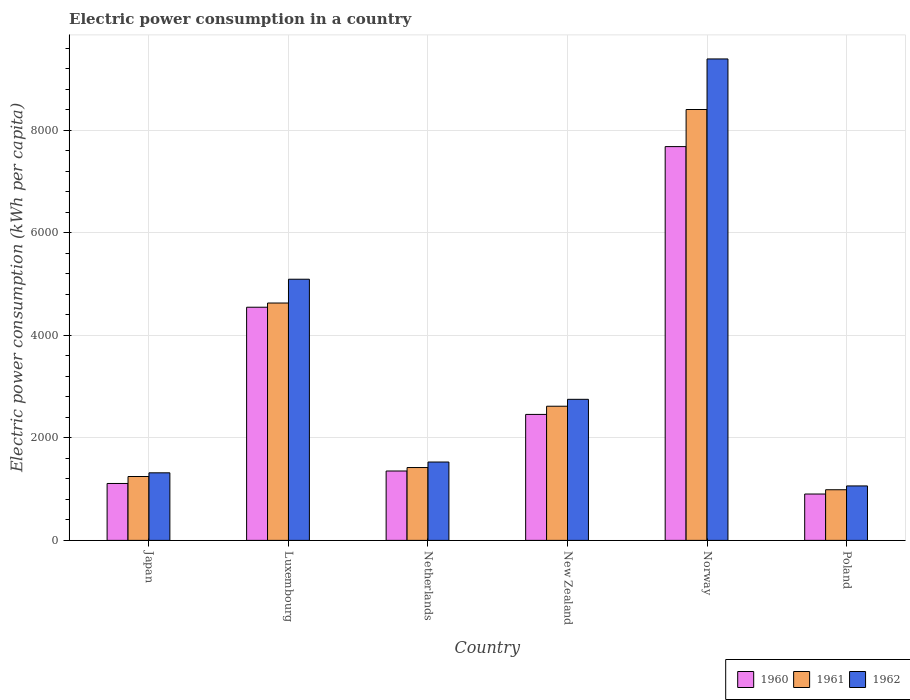How many different coloured bars are there?
Provide a short and direct response. 3. How many groups of bars are there?
Offer a terse response. 6. How many bars are there on the 4th tick from the left?
Your answer should be compact. 3. What is the label of the 3rd group of bars from the left?
Ensure brevity in your answer.  Netherlands. What is the electric power consumption in in 1962 in Luxembourg?
Ensure brevity in your answer.  5094.31. Across all countries, what is the maximum electric power consumption in in 1962?
Make the answer very short. 9390.98. Across all countries, what is the minimum electric power consumption in in 1960?
Your answer should be compact. 904.57. What is the total electric power consumption in in 1960 in the graph?
Your answer should be very brief. 1.81e+04. What is the difference between the electric power consumption in in 1962 in Japan and that in Netherlands?
Provide a succinct answer. -210.57. What is the difference between the electric power consumption in in 1961 in Norway and the electric power consumption in in 1960 in Japan?
Offer a terse response. 7294.36. What is the average electric power consumption in in 1960 per country?
Your answer should be very brief. 3009.13. What is the difference between the electric power consumption in of/in 1960 and electric power consumption in of/in 1962 in Norway?
Your answer should be very brief. -1709.84. What is the ratio of the electric power consumption in in 1961 in Netherlands to that in Poland?
Offer a very short reply. 1.44. What is the difference between the highest and the second highest electric power consumption in in 1960?
Keep it short and to the point. 5223.94. What is the difference between the highest and the lowest electric power consumption in in 1961?
Offer a terse response. 7416.7. In how many countries, is the electric power consumption in in 1961 greater than the average electric power consumption in in 1961 taken over all countries?
Offer a very short reply. 2. What does the 1st bar from the right in Netherlands represents?
Ensure brevity in your answer.  1962. Is it the case that in every country, the sum of the electric power consumption in in 1961 and electric power consumption in in 1962 is greater than the electric power consumption in in 1960?
Make the answer very short. Yes. How many bars are there?
Offer a very short reply. 18. Are all the bars in the graph horizontal?
Your answer should be very brief. No. How many countries are there in the graph?
Make the answer very short. 6. What is the difference between two consecutive major ticks on the Y-axis?
Provide a short and direct response. 2000. Are the values on the major ticks of Y-axis written in scientific E-notation?
Keep it short and to the point. No. Does the graph contain grids?
Ensure brevity in your answer.  Yes. How many legend labels are there?
Provide a succinct answer. 3. What is the title of the graph?
Provide a succinct answer. Electric power consumption in a country. Does "1973" appear as one of the legend labels in the graph?
Your answer should be very brief. No. What is the label or title of the Y-axis?
Offer a terse response. Electric power consumption (kWh per capita). What is the Electric power consumption (kWh per capita) in 1960 in Japan?
Offer a very short reply. 1110.26. What is the Electric power consumption (kWh per capita) in 1961 in Japan?
Offer a very short reply. 1246.01. What is the Electric power consumption (kWh per capita) in 1962 in Japan?
Offer a very short reply. 1317.93. What is the Electric power consumption (kWh per capita) of 1960 in Luxembourg?
Provide a succinct answer. 4548.21. What is the Electric power consumption (kWh per capita) of 1961 in Luxembourg?
Offer a terse response. 4630.02. What is the Electric power consumption (kWh per capita) of 1962 in Luxembourg?
Keep it short and to the point. 5094.31. What is the Electric power consumption (kWh per capita) in 1960 in Netherlands?
Your answer should be very brief. 1353.4. What is the Electric power consumption (kWh per capita) in 1961 in Netherlands?
Your answer should be compact. 1421.03. What is the Electric power consumption (kWh per capita) in 1962 in Netherlands?
Your answer should be compact. 1528.5. What is the Electric power consumption (kWh per capita) of 1960 in New Zealand?
Provide a short and direct response. 2457.21. What is the Electric power consumption (kWh per capita) of 1961 in New Zealand?
Ensure brevity in your answer.  2616.85. What is the Electric power consumption (kWh per capita) of 1962 in New Zealand?
Offer a terse response. 2751.81. What is the Electric power consumption (kWh per capita) in 1960 in Norway?
Your response must be concise. 7681.14. What is the Electric power consumption (kWh per capita) in 1961 in Norway?
Provide a succinct answer. 8404.62. What is the Electric power consumption (kWh per capita) of 1962 in Norway?
Provide a short and direct response. 9390.98. What is the Electric power consumption (kWh per capita) in 1960 in Poland?
Ensure brevity in your answer.  904.57. What is the Electric power consumption (kWh per capita) in 1961 in Poland?
Provide a succinct answer. 987.92. What is the Electric power consumption (kWh per capita) of 1962 in Poland?
Offer a terse response. 1062.18. Across all countries, what is the maximum Electric power consumption (kWh per capita) in 1960?
Your response must be concise. 7681.14. Across all countries, what is the maximum Electric power consumption (kWh per capita) in 1961?
Give a very brief answer. 8404.62. Across all countries, what is the maximum Electric power consumption (kWh per capita) in 1962?
Make the answer very short. 9390.98. Across all countries, what is the minimum Electric power consumption (kWh per capita) in 1960?
Make the answer very short. 904.57. Across all countries, what is the minimum Electric power consumption (kWh per capita) of 1961?
Keep it short and to the point. 987.92. Across all countries, what is the minimum Electric power consumption (kWh per capita) of 1962?
Your response must be concise. 1062.18. What is the total Electric power consumption (kWh per capita) in 1960 in the graph?
Ensure brevity in your answer.  1.81e+04. What is the total Electric power consumption (kWh per capita) of 1961 in the graph?
Keep it short and to the point. 1.93e+04. What is the total Electric power consumption (kWh per capita) of 1962 in the graph?
Ensure brevity in your answer.  2.11e+04. What is the difference between the Electric power consumption (kWh per capita) in 1960 in Japan and that in Luxembourg?
Your response must be concise. -3437.94. What is the difference between the Electric power consumption (kWh per capita) of 1961 in Japan and that in Luxembourg?
Ensure brevity in your answer.  -3384.01. What is the difference between the Electric power consumption (kWh per capita) in 1962 in Japan and that in Luxembourg?
Provide a short and direct response. -3776.38. What is the difference between the Electric power consumption (kWh per capita) of 1960 in Japan and that in Netherlands?
Offer a terse response. -243.14. What is the difference between the Electric power consumption (kWh per capita) in 1961 in Japan and that in Netherlands?
Your answer should be compact. -175.02. What is the difference between the Electric power consumption (kWh per capita) in 1962 in Japan and that in Netherlands?
Your response must be concise. -210.57. What is the difference between the Electric power consumption (kWh per capita) of 1960 in Japan and that in New Zealand?
Give a very brief answer. -1346.94. What is the difference between the Electric power consumption (kWh per capita) of 1961 in Japan and that in New Zealand?
Your answer should be very brief. -1370.84. What is the difference between the Electric power consumption (kWh per capita) of 1962 in Japan and that in New Zealand?
Offer a very short reply. -1433.88. What is the difference between the Electric power consumption (kWh per capita) of 1960 in Japan and that in Norway?
Ensure brevity in your answer.  -6570.88. What is the difference between the Electric power consumption (kWh per capita) in 1961 in Japan and that in Norway?
Offer a terse response. -7158.61. What is the difference between the Electric power consumption (kWh per capita) of 1962 in Japan and that in Norway?
Provide a succinct answer. -8073.05. What is the difference between the Electric power consumption (kWh per capita) of 1960 in Japan and that in Poland?
Provide a succinct answer. 205.7. What is the difference between the Electric power consumption (kWh per capita) in 1961 in Japan and that in Poland?
Ensure brevity in your answer.  258.09. What is the difference between the Electric power consumption (kWh per capita) of 1962 in Japan and that in Poland?
Keep it short and to the point. 255.75. What is the difference between the Electric power consumption (kWh per capita) of 1960 in Luxembourg and that in Netherlands?
Offer a terse response. 3194.81. What is the difference between the Electric power consumption (kWh per capita) of 1961 in Luxembourg and that in Netherlands?
Offer a terse response. 3208.99. What is the difference between the Electric power consumption (kWh per capita) in 1962 in Luxembourg and that in Netherlands?
Give a very brief answer. 3565.81. What is the difference between the Electric power consumption (kWh per capita) in 1960 in Luxembourg and that in New Zealand?
Make the answer very short. 2091. What is the difference between the Electric power consumption (kWh per capita) of 1961 in Luxembourg and that in New Zealand?
Your response must be concise. 2013.17. What is the difference between the Electric power consumption (kWh per capita) in 1962 in Luxembourg and that in New Zealand?
Make the answer very short. 2342.5. What is the difference between the Electric power consumption (kWh per capita) in 1960 in Luxembourg and that in Norway?
Provide a short and direct response. -3132.94. What is the difference between the Electric power consumption (kWh per capita) of 1961 in Luxembourg and that in Norway?
Offer a very short reply. -3774.6. What is the difference between the Electric power consumption (kWh per capita) in 1962 in Luxembourg and that in Norway?
Your answer should be very brief. -4296.67. What is the difference between the Electric power consumption (kWh per capita) in 1960 in Luxembourg and that in Poland?
Offer a terse response. 3643.64. What is the difference between the Electric power consumption (kWh per capita) in 1961 in Luxembourg and that in Poland?
Your answer should be compact. 3642.11. What is the difference between the Electric power consumption (kWh per capita) in 1962 in Luxembourg and that in Poland?
Your answer should be very brief. 4032.13. What is the difference between the Electric power consumption (kWh per capita) in 1960 in Netherlands and that in New Zealand?
Make the answer very short. -1103.81. What is the difference between the Electric power consumption (kWh per capita) in 1961 in Netherlands and that in New Zealand?
Give a very brief answer. -1195.82. What is the difference between the Electric power consumption (kWh per capita) of 1962 in Netherlands and that in New Zealand?
Your response must be concise. -1223.31. What is the difference between the Electric power consumption (kWh per capita) in 1960 in Netherlands and that in Norway?
Your answer should be compact. -6327.74. What is the difference between the Electric power consumption (kWh per capita) in 1961 in Netherlands and that in Norway?
Give a very brief answer. -6983.59. What is the difference between the Electric power consumption (kWh per capita) in 1962 in Netherlands and that in Norway?
Offer a very short reply. -7862.48. What is the difference between the Electric power consumption (kWh per capita) in 1960 in Netherlands and that in Poland?
Provide a short and direct response. 448.83. What is the difference between the Electric power consumption (kWh per capita) in 1961 in Netherlands and that in Poland?
Offer a very short reply. 433.11. What is the difference between the Electric power consumption (kWh per capita) of 1962 in Netherlands and that in Poland?
Give a very brief answer. 466.32. What is the difference between the Electric power consumption (kWh per capita) of 1960 in New Zealand and that in Norway?
Offer a terse response. -5223.94. What is the difference between the Electric power consumption (kWh per capita) in 1961 in New Zealand and that in Norway?
Provide a short and direct response. -5787.77. What is the difference between the Electric power consumption (kWh per capita) of 1962 in New Zealand and that in Norway?
Ensure brevity in your answer.  -6639.17. What is the difference between the Electric power consumption (kWh per capita) in 1960 in New Zealand and that in Poland?
Offer a terse response. 1552.64. What is the difference between the Electric power consumption (kWh per capita) of 1961 in New Zealand and that in Poland?
Offer a very short reply. 1628.93. What is the difference between the Electric power consumption (kWh per capita) of 1962 in New Zealand and that in Poland?
Your answer should be compact. 1689.64. What is the difference between the Electric power consumption (kWh per capita) in 1960 in Norway and that in Poland?
Offer a terse response. 6776.58. What is the difference between the Electric power consumption (kWh per capita) in 1961 in Norway and that in Poland?
Ensure brevity in your answer.  7416.7. What is the difference between the Electric power consumption (kWh per capita) in 1962 in Norway and that in Poland?
Your response must be concise. 8328.8. What is the difference between the Electric power consumption (kWh per capita) in 1960 in Japan and the Electric power consumption (kWh per capita) in 1961 in Luxembourg?
Your response must be concise. -3519.76. What is the difference between the Electric power consumption (kWh per capita) of 1960 in Japan and the Electric power consumption (kWh per capita) of 1962 in Luxembourg?
Keep it short and to the point. -3984.05. What is the difference between the Electric power consumption (kWh per capita) in 1961 in Japan and the Electric power consumption (kWh per capita) in 1962 in Luxembourg?
Your answer should be very brief. -3848.3. What is the difference between the Electric power consumption (kWh per capita) in 1960 in Japan and the Electric power consumption (kWh per capita) in 1961 in Netherlands?
Your answer should be compact. -310.77. What is the difference between the Electric power consumption (kWh per capita) of 1960 in Japan and the Electric power consumption (kWh per capita) of 1962 in Netherlands?
Offer a terse response. -418.24. What is the difference between the Electric power consumption (kWh per capita) in 1961 in Japan and the Electric power consumption (kWh per capita) in 1962 in Netherlands?
Provide a short and direct response. -282.49. What is the difference between the Electric power consumption (kWh per capita) of 1960 in Japan and the Electric power consumption (kWh per capita) of 1961 in New Zealand?
Provide a short and direct response. -1506.59. What is the difference between the Electric power consumption (kWh per capita) of 1960 in Japan and the Electric power consumption (kWh per capita) of 1962 in New Zealand?
Provide a short and direct response. -1641.55. What is the difference between the Electric power consumption (kWh per capita) in 1961 in Japan and the Electric power consumption (kWh per capita) in 1962 in New Zealand?
Provide a short and direct response. -1505.8. What is the difference between the Electric power consumption (kWh per capita) of 1960 in Japan and the Electric power consumption (kWh per capita) of 1961 in Norway?
Provide a succinct answer. -7294.36. What is the difference between the Electric power consumption (kWh per capita) of 1960 in Japan and the Electric power consumption (kWh per capita) of 1962 in Norway?
Make the answer very short. -8280.71. What is the difference between the Electric power consumption (kWh per capita) in 1961 in Japan and the Electric power consumption (kWh per capita) in 1962 in Norway?
Provide a succinct answer. -8144.97. What is the difference between the Electric power consumption (kWh per capita) in 1960 in Japan and the Electric power consumption (kWh per capita) in 1961 in Poland?
Your response must be concise. 122.34. What is the difference between the Electric power consumption (kWh per capita) of 1960 in Japan and the Electric power consumption (kWh per capita) of 1962 in Poland?
Ensure brevity in your answer.  48.09. What is the difference between the Electric power consumption (kWh per capita) of 1961 in Japan and the Electric power consumption (kWh per capita) of 1962 in Poland?
Provide a succinct answer. 183.83. What is the difference between the Electric power consumption (kWh per capita) of 1960 in Luxembourg and the Electric power consumption (kWh per capita) of 1961 in Netherlands?
Ensure brevity in your answer.  3127.17. What is the difference between the Electric power consumption (kWh per capita) in 1960 in Luxembourg and the Electric power consumption (kWh per capita) in 1962 in Netherlands?
Your answer should be very brief. 3019.7. What is the difference between the Electric power consumption (kWh per capita) in 1961 in Luxembourg and the Electric power consumption (kWh per capita) in 1962 in Netherlands?
Provide a short and direct response. 3101.52. What is the difference between the Electric power consumption (kWh per capita) of 1960 in Luxembourg and the Electric power consumption (kWh per capita) of 1961 in New Zealand?
Make the answer very short. 1931.35. What is the difference between the Electric power consumption (kWh per capita) in 1960 in Luxembourg and the Electric power consumption (kWh per capita) in 1962 in New Zealand?
Ensure brevity in your answer.  1796.39. What is the difference between the Electric power consumption (kWh per capita) of 1961 in Luxembourg and the Electric power consumption (kWh per capita) of 1962 in New Zealand?
Offer a very short reply. 1878.21. What is the difference between the Electric power consumption (kWh per capita) of 1960 in Luxembourg and the Electric power consumption (kWh per capita) of 1961 in Norway?
Your answer should be very brief. -3856.42. What is the difference between the Electric power consumption (kWh per capita) of 1960 in Luxembourg and the Electric power consumption (kWh per capita) of 1962 in Norway?
Offer a terse response. -4842.77. What is the difference between the Electric power consumption (kWh per capita) of 1961 in Luxembourg and the Electric power consumption (kWh per capita) of 1962 in Norway?
Ensure brevity in your answer.  -4760.95. What is the difference between the Electric power consumption (kWh per capita) in 1960 in Luxembourg and the Electric power consumption (kWh per capita) in 1961 in Poland?
Ensure brevity in your answer.  3560.29. What is the difference between the Electric power consumption (kWh per capita) of 1960 in Luxembourg and the Electric power consumption (kWh per capita) of 1962 in Poland?
Offer a very short reply. 3486.03. What is the difference between the Electric power consumption (kWh per capita) of 1961 in Luxembourg and the Electric power consumption (kWh per capita) of 1962 in Poland?
Provide a short and direct response. 3567.85. What is the difference between the Electric power consumption (kWh per capita) in 1960 in Netherlands and the Electric power consumption (kWh per capita) in 1961 in New Zealand?
Offer a very short reply. -1263.45. What is the difference between the Electric power consumption (kWh per capita) in 1960 in Netherlands and the Electric power consumption (kWh per capita) in 1962 in New Zealand?
Provide a short and direct response. -1398.41. What is the difference between the Electric power consumption (kWh per capita) in 1961 in Netherlands and the Electric power consumption (kWh per capita) in 1962 in New Zealand?
Your answer should be compact. -1330.78. What is the difference between the Electric power consumption (kWh per capita) in 1960 in Netherlands and the Electric power consumption (kWh per capita) in 1961 in Norway?
Ensure brevity in your answer.  -7051.22. What is the difference between the Electric power consumption (kWh per capita) in 1960 in Netherlands and the Electric power consumption (kWh per capita) in 1962 in Norway?
Your answer should be compact. -8037.58. What is the difference between the Electric power consumption (kWh per capita) of 1961 in Netherlands and the Electric power consumption (kWh per capita) of 1962 in Norway?
Offer a terse response. -7969.94. What is the difference between the Electric power consumption (kWh per capita) of 1960 in Netherlands and the Electric power consumption (kWh per capita) of 1961 in Poland?
Provide a short and direct response. 365.48. What is the difference between the Electric power consumption (kWh per capita) of 1960 in Netherlands and the Electric power consumption (kWh per capita) of 1962 in Poland?
Make the answer very short. 291.22. What is the difference between the Electric power consumption (kWh per capita) of 1961 in Netherlands and the Electric power consumption (kWh per capita) of 1962 in Poland?
Ensure brevity in your answer.  358.86. What is the difference between the Electric power consumption (kWh per capita) of 1960 in New Zealand and the Electric power consumption (kWh per capita) of 1961 in Norway?
Your response must be concise. -5947.42. What is the difference between the Electric power consumption (kWh per capita) in 1960 in New Zealand and the Electric power consumption (kWh per capita) in 1962 in Norway?
Your answer should be compact. -6933.77. What is the difference between the Electric power consumption (kWh per capita) in 1961 in New Zealand and the Electric power consumption (kWh per capita) in 1962 in Norway?
Offer a very short reply. -6774.12. What is the difference between the Electric power consumption (kWh per capita) of 1960 in New Zealand and the Electric power consumption (kWh per capita) of 1961 in Poland?
Provide a short and direct response. 1469.29. What is the difference between the Electric power consumption (kWh per capita) in 1960 in New Zealand and the Electric power consumption (kWh per capita) in 1962 in Poland?
Offer a very short reply. 1395.03. What is the difference between the Electric power consumption (kWh per capita) of 1961 in New Zealand and the Electric power consumption (kWh per capita) of 1962 in Poland?
Make the answer very short. 1554.68. What is the difference between the Electric power consumption (kWh per capita) of 1960 in Norway and the Electric power consumption (kWh per capita) of 1961 in Poland?
Make the answer very short. 6693.22. What is the difference between the Electric power consumption (kWh per capita) of 1960 in Norway and the Electric power consumption (kWh per capita) of 1962 in Poland?
Ensure brevity in your answer.  6618.96. What is the difference between the Electric power consumption (kWh per capita) of 1961 in Norway and the Electric power consumption (kWh per capita) of 1962 in Poland?
Make the answer very short. 7342.44. What is the average Electric power consumption (kWh per capita) of 1960 per country?
Your answer should be very brief. 3009.13. What is the average Electric power consumption (kWh per capita) of 1961 per country?
Your response must be concise. 3217.74. What is the average Electric power consumption (kWh per capita) of 1962 per country?
Your answer should be very brief. 3524.29. What is the difference between the Electric power consumption (kWh per capita) of 1960 and Electric power consumption (kWh per capita) of 1961 in Japan?
Give a very brief answer. -135.75. What is the difference between the Electric power consumption (kWh per capita) in 1960 and Electric power consumption (kWh per capita) in 1962 in Japan?
Your answer should be compact. -207.67. What is the difference between the Electric power consumption (kWh per capita) of 1961 and Electric power consumption (kWh per capita) of 1962 in Japan?
Provide a short and direct response. -71.92. What is the difference between the Electric power consumption (kWh per capita) of 1960 and Electric power consumption (kWh per capita) of 1961 in Luxembourg?
Provide a succinct answer. -81.82. What is the difference between the Electric power consumption (kWh per capita) of 1960 and Electric power consumption (kWh per capita) of 1962 in Luxembourg?
Keep it short and to the point. -546.11. What is the difference between the Electric power consumption (kWh per capita) in 1961 and Electric power consumption (kWh per capita) in 1962 in Luxembourg?
Your response must be concise. -464.29. What is the difference between the Electric power consumption (kWh per capita) of 1960 and Electric power consumption (kWh per capita) of 1961 in Netherlands?
Offer a very short reply. -67.63. What is the difference between the Electric power consumption (kWh per capita) in 1960 and Electric power consumption (kWh per capita) in 1962 in Netherlands?
Offer a terse response. -175.1. What is the difference between the Electric power consumption (kWh per capita) of 1961 and Electric power consumption (kWh per capita) of 1962 in Netherlands?
Make the answer very short. -107.47. What is the difference between the Electric power consumption (kWh per capita) of 1960 and Electric power consumption (kWh per capita) of 1961 in New Zealand?
Keep it short and to the point. -159.65. What is the difference between the Electric power consumption (kWh per capita) of 1960 and Electric power consumption (kWh per capita) of 1962 in New Zealand?
Offer a very short reply. -294.61. What is the difference between the Electric power consumption (kWh per capita) in 1961 and Electric power consumption (kWh per capita) in 1962 in New Zealand?
Your answer should be very brief. -134.96. What is the difference between the Electric power consumption (kWh per capita) in 1960 and Electric power consumption (kWh per capita) in 1961 in Norway?
Offer a terse response. -723.48. What is the difference between the Electric power consumption (kWh per capita) of 1960 and Electric power consumption (kWh per capita) of 1962 in Norway?
Offer a terse response. -1709.84. What is the difference between the Electric power consumption (kWh per capita) of 1961 and Electric power consumption (kWh per capita) of 1962 in Norway?
Your response must be concise. -986.36. What is the difference between the Electric power consumption (kWh per capita) in 1960 and Electric power consumption (kWh per capita) in 1961 in Poland?
Ensure brevity in your answer.  -83.35. What is the difference between the Electric power consumption (kWh per capita) of 1960 and Electric power consumption (kWh per capita) of 1962 in Poland?
Your answer should be very brief. -157.61. What is the difference between the Electric power consumption (kWh per capita) of 1961 and Electric power consumption (kWh per capita) of 1962 in Poland?
Your answer should be compact. -74.26. What is the ratio of the Electric power consumption (kWh per capita) in 1960 in Japan to that in Luxembourg?
Your answer should be very brief. 0.24. What is the ratio of the Electric power consumption (kWh per capita) of 1961 in Japan to that in Luxembourg?
Your answer should be very brief. 0.27. What is the ratio of the Electric power consumption (kWh per capita) in 1962 in Japan to that in Luxembourg?
Give a very brief answer. 0.26. What is the ratio of the Electric power consumption (kWh per capita) in 1960 in Japan to that in Netherlands?
Your answer should be very brief. 0.82. What is the ratio of the Electric power consumption (kWh per capita) in 1961 in Japan to that in Netherlands?
Offer a terse response. 0.88. What is the ratio of the Electric power consumption (kWh per capita) in 1962 in Japan to that in Netherlands?
Provide a short and direct response. 0.86. What is the ratio of the Electric power consumption (kWh per capita) in 1960 in Japan to that in New Zealand?
Keep it short and to the point. 0.45. What is the ratio of the Electric power consumption (kWh per capita) in 1961 in Japan to that in New Zealand?
Ensure brevity in your answer.  0.48. What is the ratio of the Electric power consumption (kWh per capita) of 1962 in Japan to that in New Zealand?
Offer a very short reply. 0.48. What is the ratio of the Electric power consumption (kWh per capita) of 1960 in Japan to that in Norway?
Provide a short and direct response. 0.14. What is the ratio of the Electric power consumption (kWh per capita) of 1961 in Japan to that in Norway?
Keep it short and to the point. 0.15. What is the ratio of the Electric power consumption (kWh per capita) in 1962 in Japan to that in Norway?
Your answer should be very brief. 0.14. What is the ratio of the Electric power consumption (kWh per capita) in 1960 in Japan to that in Poland?
Your answer should be very brief. 1.23. What is the ratio of the Electric power consumption (kWh per capita) of 1961 in Japan to that in Poland?
Make the answer very short. 1.26. What is the ratio of the Electric power consumption (kWh per capita) of 1962 in Japan to that in Poland?
Offer a terse response. 1.24. What is the ratio of the Electric power consumption (kWh per capita) in 1960 in Luxembourg to that in Netherlands?
Give a very brief answer. 3.36. What is the ratio of the Electric power consumption (kWh per capita) of 1961 in Luxembourg to that in Netherlands?
Ensure brevity in your answer.  3.26. What is the ratio of the Electric power consumption (kWh per capita) in 1962 in Luxembourg to that in Netherlands?
Offer a terse response. 3.33. What is the ratio of the Electric power consumption (kWh per capita) in 1960 in Luxembourg to that in New Zealand?
Your response must be concise. 1.85. What is the ratio of the Electric power consumption (kWh per capita) in 1961 in Luxembourg to that in New Zealand?
Provide a succinct answer. 1.77. What is the ratio of the Electric power consumption (kWh per capita) in 1962 in Luxembourg to that in New Zealand?
Ensure brevity in your answer.  1.85. What is the ratio of the Electric power consumption (kWh per capita) of 1960 in Luxembourg to that in Norway?
Offer a very short reply. 0.59. What is the ratio of the Electric power consumption (kWh per capita) of 1961 in Luxembourg to that in Norway?
Keep it short and to the point. 0.55. What is the ratio of the Electric power consumption (kWh per capita) of 1962 in Luxembourg to that in Norway?
Offer a very short reply. 0.54. What is the ratio of the Electric power consumption (kWh per capita) in 1960 in Luxembourg to that in Poland?
Provide a short and direct response. 5.03. What is the ratio of the Electric power consumption (kWh per capita) of 1961 in Luxembourg to that in Poland?
Provide a short and direct response. 4.69. What is the ratio of the Electric power consumption (kWh per capita) in 1962 in Luxembourg to that in Poland?
Offer a terse response. 4.8. What is the ratio of the Electric power consumption (kWh per capita) in 1960 in Netherlands to that in New Zealand?
Keep it short and to the point. 0.55. What is the ratio of the Electric power consumption (kWh per capita) of 1961 in Netherlands to that in New Zealand?
Provide a short and direct response. 0.54. What is the ratio of the Electric power consumption (kWh per capita) in 1962 in Netherlands to that in New Zealand?
Keep it short and to the point. 0.56. What is the ratio of the Electric power consumption (kWh per capita) in 1960 in Netherlands to that in Norway?
Make the answer very short. 0.18. What is the ratio of the Electric power consumption (kWh per capita) in 1961 in Netherlands to that in Norway?
Ensure brevity in your answer.  0.17. What is the ratio of the Electric power consumption (kWh per capita) of 1962 in Netherlands to that in Norway?
Offer a very short reply. 0.16. What is the ratio of the Electric power consumption (kWh per capita) of 1960 in Netherlands to that in Poland?
Provide a succinct answer. 1.5. What is the ratio of the Electric power consumption (kWh per capita) of 1961 in Netherlands to that in Poland?
Your answer should be compact. 1.44. What is the ratio of the Electric power consumption (kWh per capita) in 1962 in Netherlands to that in Poland?
Your answer should be compact. 1.44. What is the ratio of the Electric power consumption (kWh per capita) of 1960 in New Zealand to that in Norway?
Your answer should be compact. 0.32. What is the ratio of the Electric power consumption (kWh per capita) of 1961 in New Zealand to that in Norway?
Give a very brief answer. 0.31. What is the ratio of the Electric power consumption (kWh per capita) of 1962 in New Zealand to that in Norway?
Offer a very short reply. 0.29. What is the ratio of the Electric power consumption (kWh per capita) in 1960 in New Zealand to that in Poland?
Your answer should be very brief. 2.72. What is the ratio of the Electric power consumption (kWh per capita) of 1961 in New Zealand to that in Poland?
Provide a short and direct response. 2.65. What is the ratio of the Electric power consumption (kWh per capita) of 1962 in New Zealand to that in Poland?
Provide a short and direct response. 2.59. What is the ratio of the Electric power consumption (kWh per capita) in 1960 in Norway to that in Poland?
Make the answer very short. 8.49. What is the ratio of the Electric power consumption (kWh per capita) in 1961 in Norway to that in Poland?
Provide a short and direct response. 8.51. What is the ratio of the Electric power consumption (kWh per capita) in 1962 in Norway to that in Poland?
Keep it short and to the point. 8.84. What is the difference between the highest and the second highest Electric power consumption (kWh per capita) in 1960?
Provide a succinct answer. 3132.94. What is the difference between the highest and the second highest Electric power consumption (kWh per capita) of 1961?
Your response must be concise. 3774.6. What is the difference between the highest and the second highest Electric power consumption (kWh per capita) in 1962?
Provide a succinct answer. 4296.67. What is the difference between the highest and the lowest Electric power consumption (kWh per capita) of 1960?
Your response must be concise. 6776.58. What is the difference between the highest and the lowest Electric power consumption (kWh per capita) in 1961?
Make the answer very short. 7416.7. What is the difference between the highest and the lowest Electric power consumption (kWh per capita) of 1962?
Provide a succinct answer. 8328.8. 